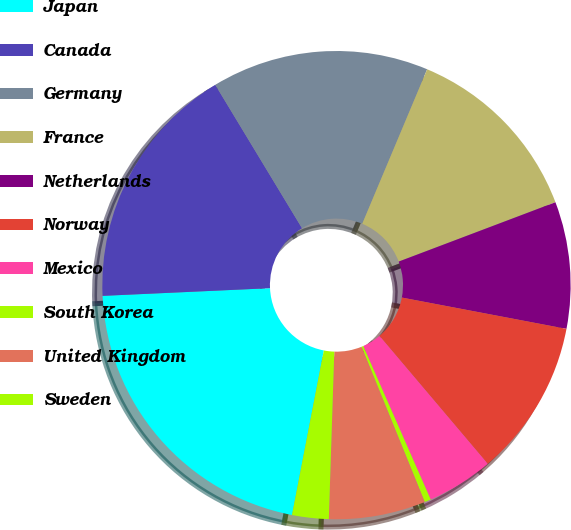Convert chart. <chart><loc_0><loc_0><loc_500><loc_500><pie_chart><fcel>Japan<fcel>Canada<fcel>Germany<fcel>France<fcel>Netherlands<fcel>Norway<fcel>Mexico<fcel>South Korea<fcel>United Kingdom<fcel>Sweden<nl><fcel>21.23%<fcel>17.07%<fcel>14.99%<fcel>12.91%<fcel>8.75%<fcel>10.83%<fcel>4.59%<fcel>0.44%<fcel>6.67%<fcel>2.52%<nl></chart> 